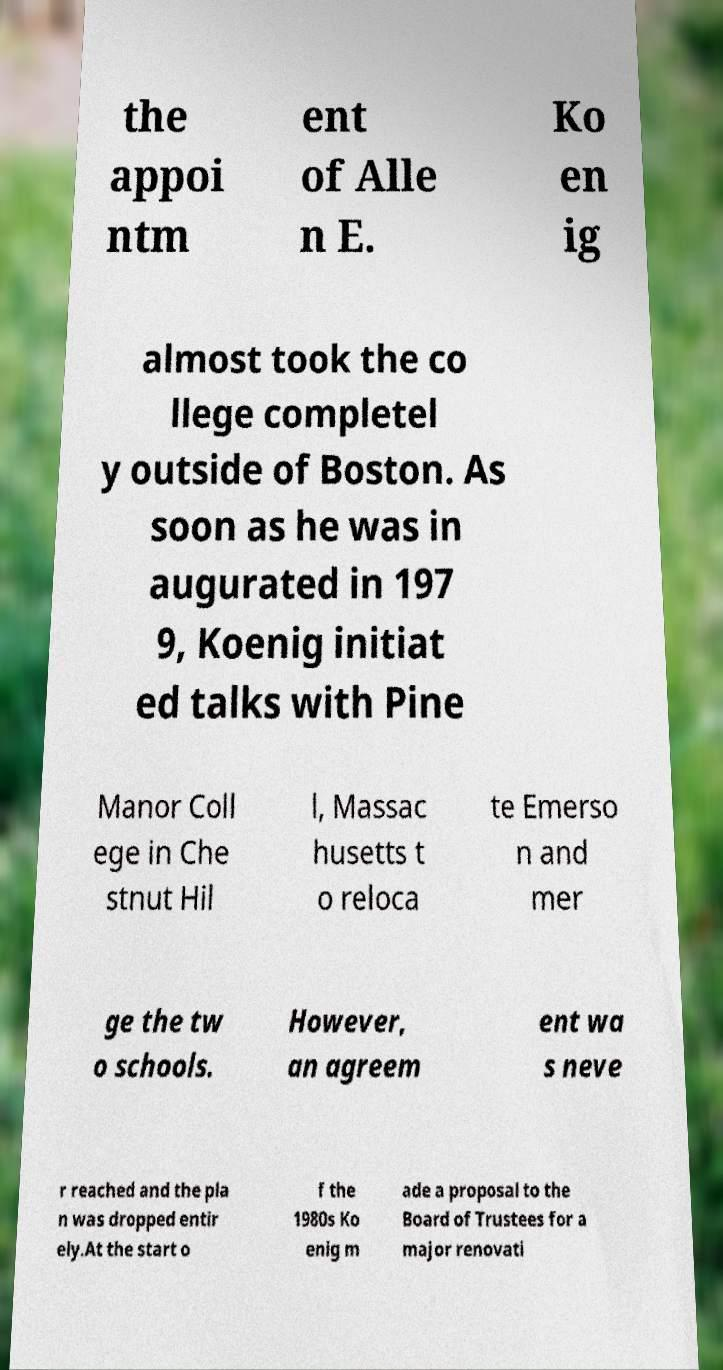Can you accurately transcribe the text from the provided image for me? the appoi ntm ent of Alle n E. Ko en ig almost took the co llege completel y outside of Boston. As soon as he was in augurated in 197 9, Koenig initiat ed talks with Pine Manor Coll ege in Che stnut Hil l, Massac husetts t o reloca te Emerso n and mer ge the tw o schools. However, an agreem ent wa s neve r reached and the pla n was dropped entir ely.At the start o f the 1980s Ko enig m ade a proposal to the Board of Trustees for a major renovati 